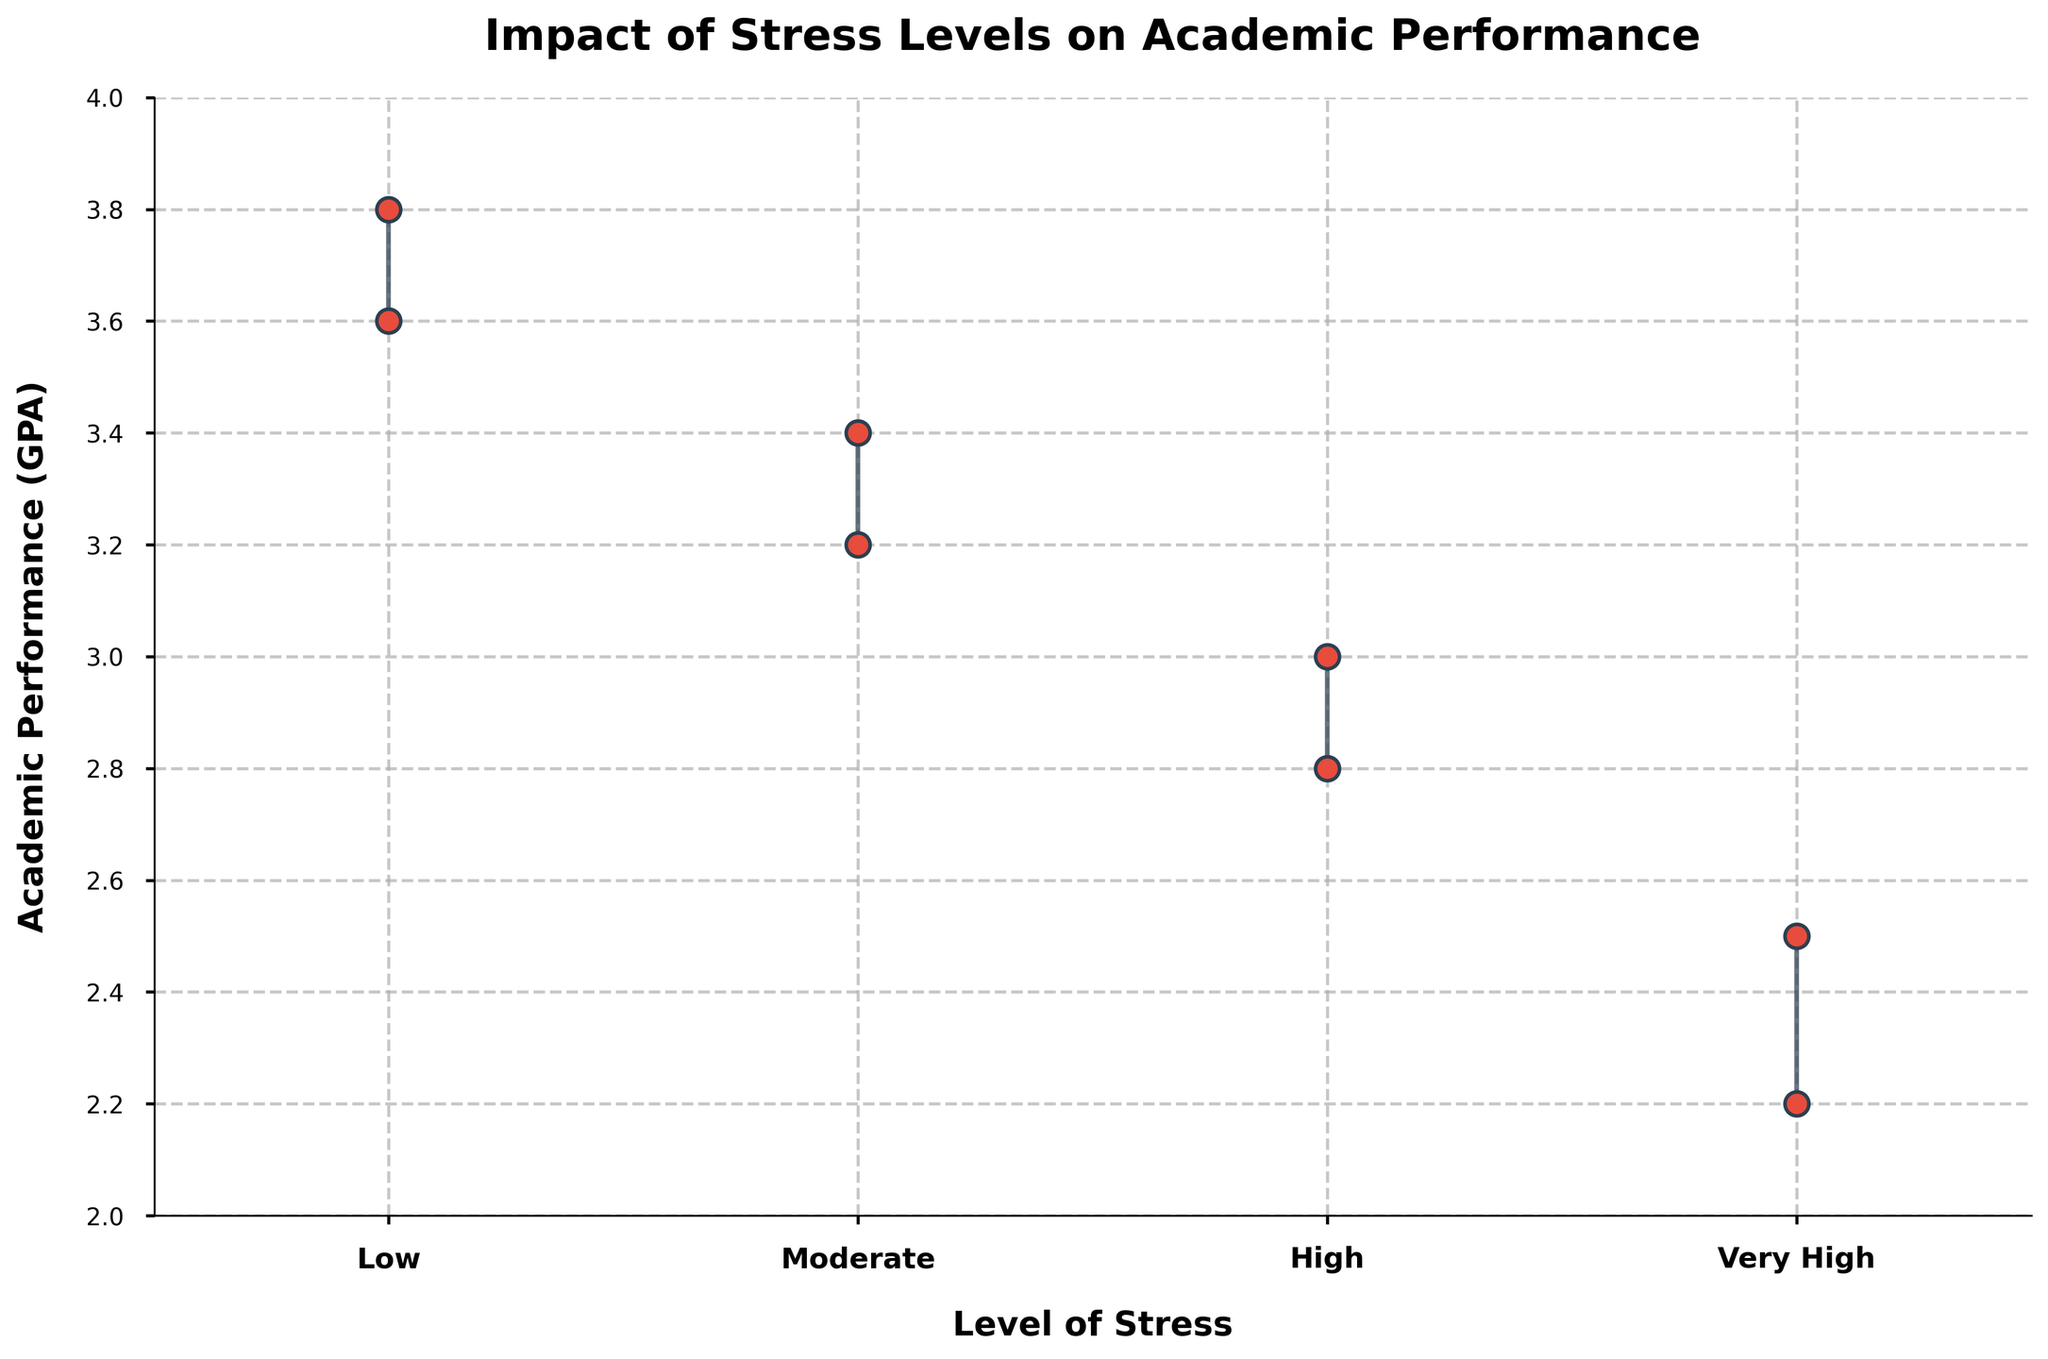what is the title of the plot? The title of the plot is displayed prominently at the top. It reads, "Impact of Stress Levels on Academic Performance"
Answer: Impact of Stress Levels on Academic Performance how many stress levels are represented in the plot? The x-axis of the plot lists all the stress levels being measured. There are four stress levels: Low, Moderate, High, and Very High.
Answer: Four which individual student has the highest academic performance? John Doe and Jane Smith both have the highest GPA, which can be seen by identifying the individual points near the top of the y-axis under the "Low" stress level.
Answer: John Doe and Jane Smith what is the range of academic performance for students with moderate stress? To find the range, look at the line connected to the "Moderate" stress level on the x-axis. The bottom of the range touches 3.2 and the top reaches 3.4. The range then is from 3.2 to 3.4.
Answer: 3.2 to 3.4 which stress level shows the most variation in academic performance? By comparing the lengths of the vertical lines at different stress levels, "Low" stress level shows the most variation, with values ranging from 3.6 to 3.8.
Answer: Low how does academic performance change as stress increases from low to very high? Observing the plotted points from "Low" to "Very High" stress levels, there is a clear downward trend in academic performance, indicating that higher stress correlates with lower performance.
Answer: Decreases what is the minimum academic performance for the highest stress level? Look at the bottom point in the "Very High" category. The minimum GPA for students in the very high stress level is illustrated by David Moore's performance at 2.2.
Answer: 2.2 which two stress levels have identical ranges for academic performance? Looking at the vertical lines, it is evident that "High" and "Very High" levels both have a range that extends from 2.8 to 3.0 for "High" and from 2.2 to 2.5 for "Very High". On further reading, it is "Moderate" and "Very High" that have distinctly different ranges. No two levels have identical ranges.
Answer: None which stress level has the second lowest average academic performance? Calculate the average GPA for each level. For "Low" (3.8 + 3.6)/2 = 3.7, "Moderate" (3.4 + 3.2)/2 = 3.3, "High" (3.0 + 2.8)/2 = 2.9, and "Very High" (2.5 + 2.2)/2 = 2.35. The second lowest average is for "High".
Answer: High is there any stress level where all the students have the same academic performance? By examining each stress level, it becomes clear that no stress category has identical GPA values for all its students. Every level shows some variation among students' academic performance.
Answer: No 